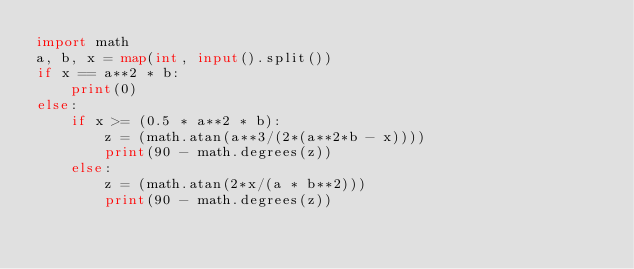<code> <loc_0><loc_0><loc_500><loc_500><_Python_>import math
a, b, x = map(int, input().split())
if x == a**2 * b:
    print(0)
else:
    if x >= (0.5 * a**2 * b):
        z = (math.atan(a**3/(2*(a**2*b - x))))
        print(90 - math.degrees(z))
    else:
        z = (math.atan(2*x/(a * b**2)))
        print(90 - math.degrees(z))</code> 